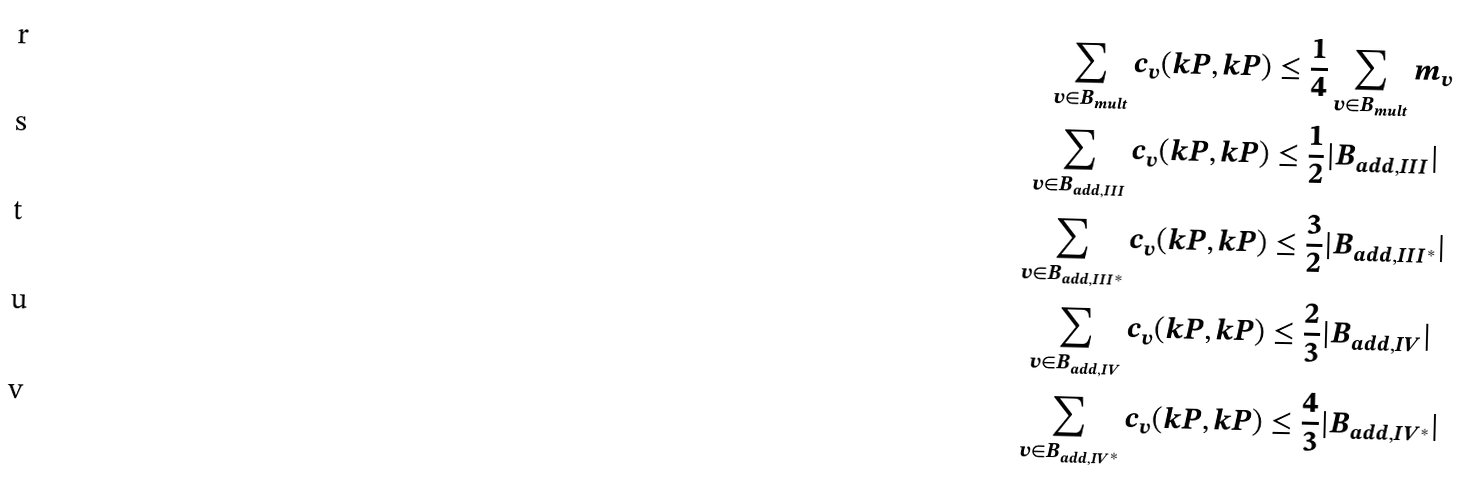<formula> <loc_0><loc_0><loc_500><loc_500>\sum _ { v \in B _ { m u l t } } c _ { v } ( k P , k P ) & \leq \frac { 1 } { 4 } \sum _ { v \in B _ { m u l t } } m _ { v } \\ \sum _ { v \in B _ { a d d , I I I } } c _ { v } ( k P , k P ) & \leq \frac { 1 } { 2 } | B _ { a d d , I I I } | \\ \sum _ { v \in B _ { a d d , I I I ^ { * } } } c _ { v } ( k P , k P ) & \leq \frac { 3 } { 2 } | B _ { a d d , I I I ^ { * } } | \\ \sum _ { v \in B _ { a d d , I V } } c _ { v } ( k P , k P ) & \leq \frac { 2 } { 3 } | B _ { a d d , I V } | \\ \sum _ { v \in B _ { a d d , I V ^ { * } } } c _ { v } ( k P , k P ) & \leq \frac { 4 } { 3 } | B _ { a d d , I V ^ { * } } |</formula> 